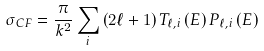<formula> <loc_0><loc_0><loc_500><loc_500>\sigma _ { C F } = \frac { \pi } { k ^ { 2 } } \sum _ { i } \left ( 2 \ell + 1 \right ) T _ { \ell , i } \left ( E \right ) P _ { \ell , i } \left ( E \right )</formula> 